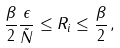Convert formula to latex. <formula><loc_0><loc_0><loc_500><loc_500>\frac { \beta } { 2 } \frac { \epsilon } { \tilde { N } } \leq R _ { i } \leq \frac { \beta } { 2 } \, ,</formula> 